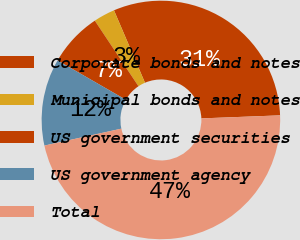Convert chart. <chart><loc_0><loc_0><loc_500><loc_500><pie_chart><fcel>Corporate bonds and notes<fcel>Municipal bonds and notes<fcel>US government securities<fcel>US government agency<fcel>Total<nl><fcel>30.82%<fcel>2.91%<fcel>7.34%<fcel>11.76%<fcel>47.17%<nl></chart> 